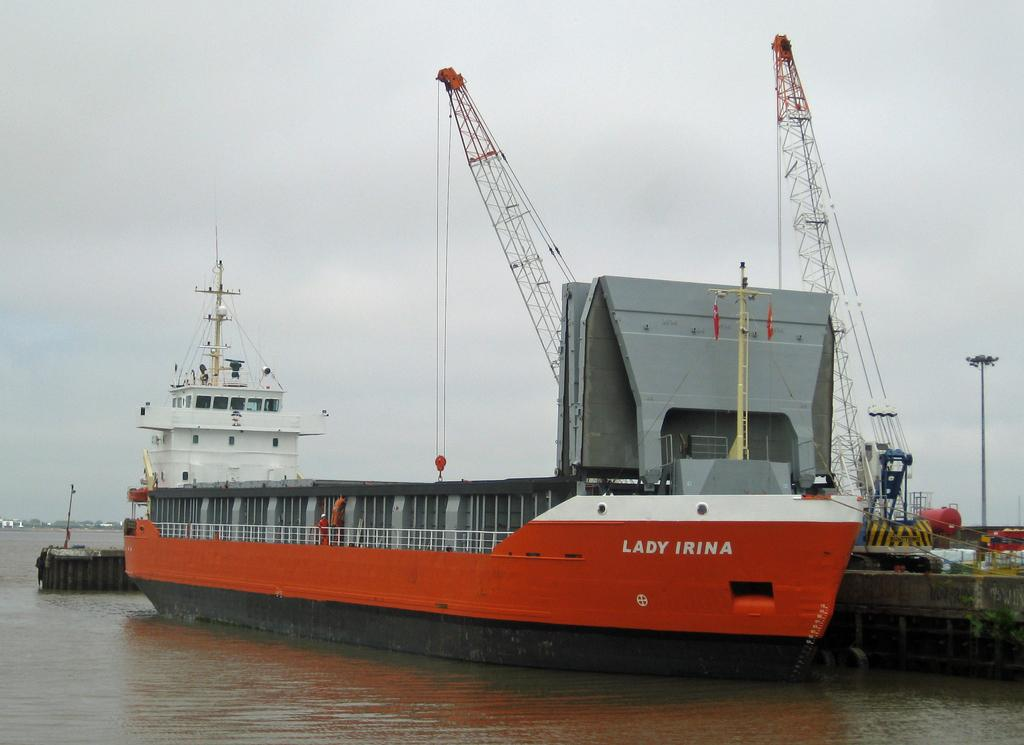Provide a one-sentence caption for the provided image. The ship Lady Irina sits at the dock. 